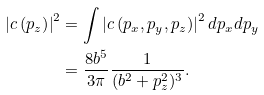<formula> <loc_0><loc_0><loc_500><loc_500>\left | c \left ( p _ { z } \right ) \right | ^ { 2 } & = \int \left | c \left ( p _ { x } , p _ { y } , p _ { z } \right ) \right | ^ { 2 } d p _ { x } d p _ { y } \\ & = \frac { 8 b ^ { 5 } } { 3 \pi } \frac { 1 } { ( b ^ { 2 } + p _ { z } ^ { 2 } ) ^ { 3 } } .</formula> 